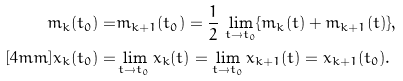Convert formula to latex. <formula><loc_0><loc_0><loc_500><loc_500>m _ { k } ( t _ { 0 } ) = & m _ { k + 1 } ( t _ { 0 } ) = \frac { 1 } { 2 } \, \lim _ { t \to t _ { 0 } } \{ m _ { k } ( t ) + m _ { k + 1 } ( t ) \} , \\ [ 4 m m ] x _ { k } ( t _ { 0 } ) = & \lim _ { t \to t _ { 0 } } x _ { k } ( t ) = \lim _ { t \to t _ { 0 } } x _ { k + 1 } ( t ) = x _ { k + 1 } ( t _ { 0 } ) .</formula> 